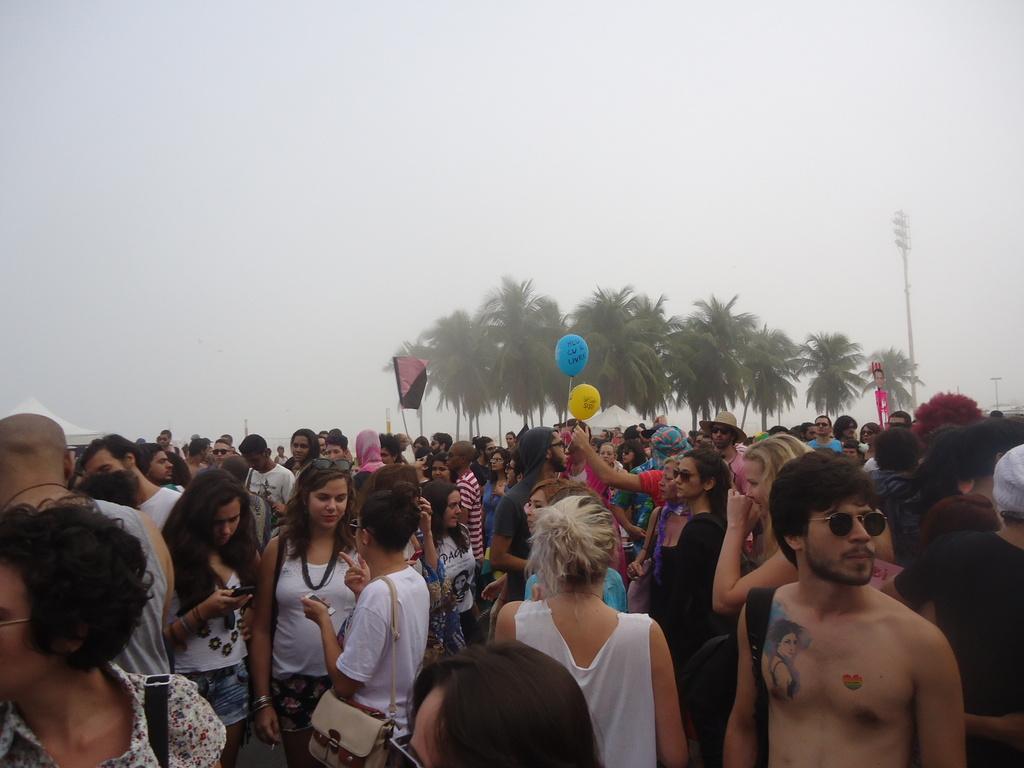Please provide a concise description of this image. In this image I can see number of people are standing. In the background I can see few balloons, a flag, number of trees, a red colour board and a pole. 